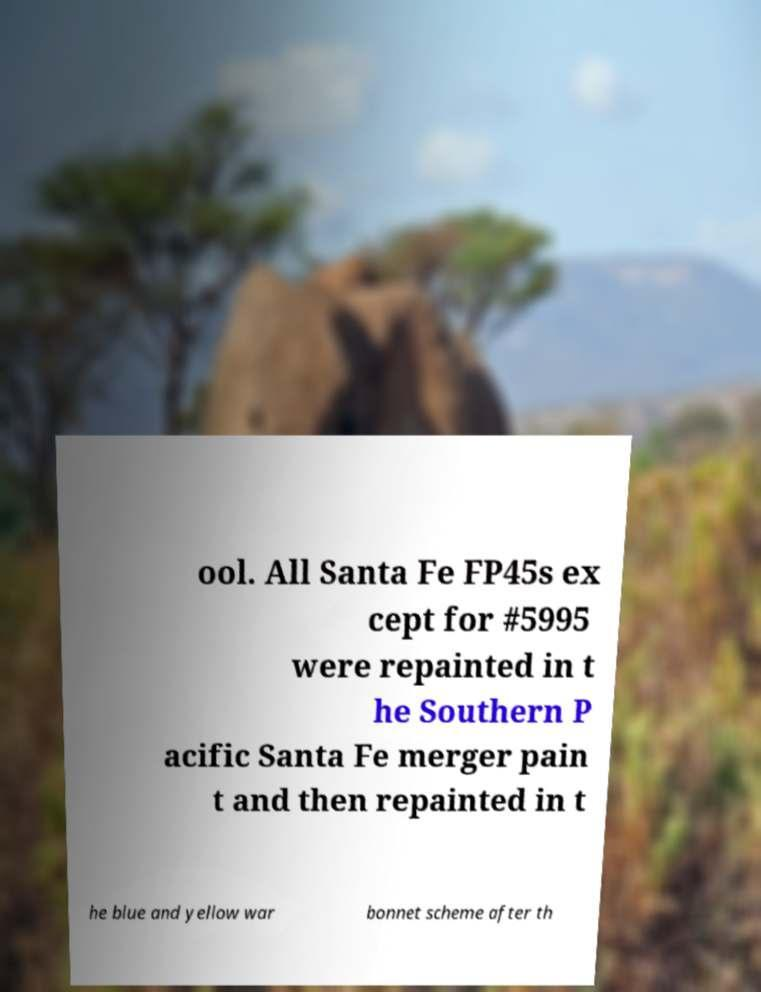What messages or text are displayed in this image? I need them in a readable, typed format. ool. All Santa Fe FP45s ex cept for #5995 were repainted in t he Southern P acific Santa Fe merger pain t and then repainted in t he blue and yellow war bonnet scheme after th 